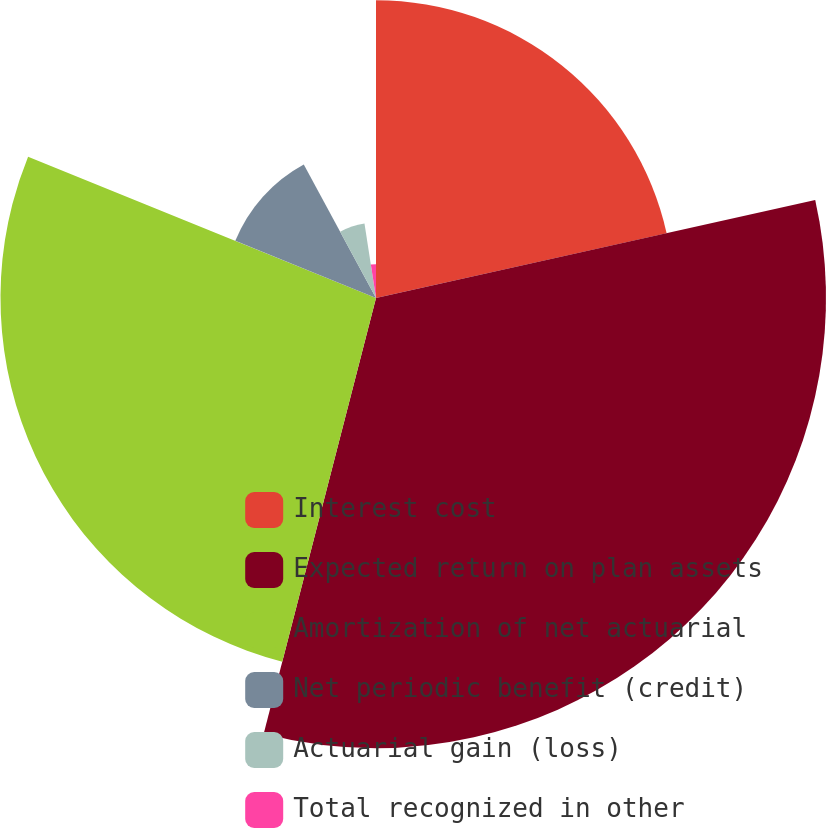Convert chart to OTSL. <chart><loc_0><loc_0><loc_500><loc_500><pie_chart><fcel>Interest cost<fcel>Expected return on plan assets<fcel>Amortization of net actuarial<fcel>Net periodic benefit (credit)<fcel>Actuarial gain (loss)<fcel>Total recognized in other<nl><fcel>21.51%<fcel>32.51%<fcel>27.13%<fcel>10.97%<fcel>5.45%<fcel>2.44%<nl></chart> 